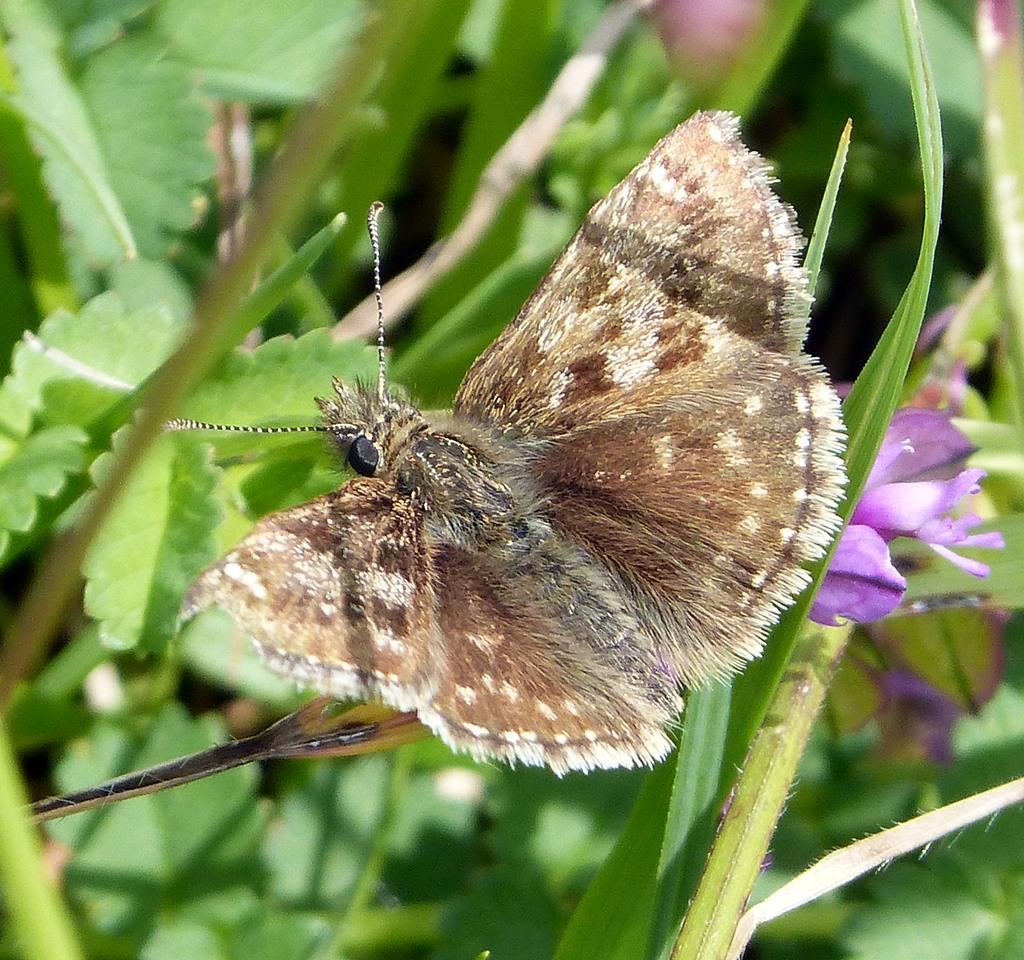What is the main subject of the picture? The main subject of the picture is a butterfly. What can be seen in the background of the picture? There are plants and flowers in the background of the picture. How thick is the fog in the image? There is no fog present in the image; it features a butterfly and plants in the background. What type of locket is hanging from the butterfly's antennae in the image? There is no locket present in the image; it only features a butterfly and plants in the background. 